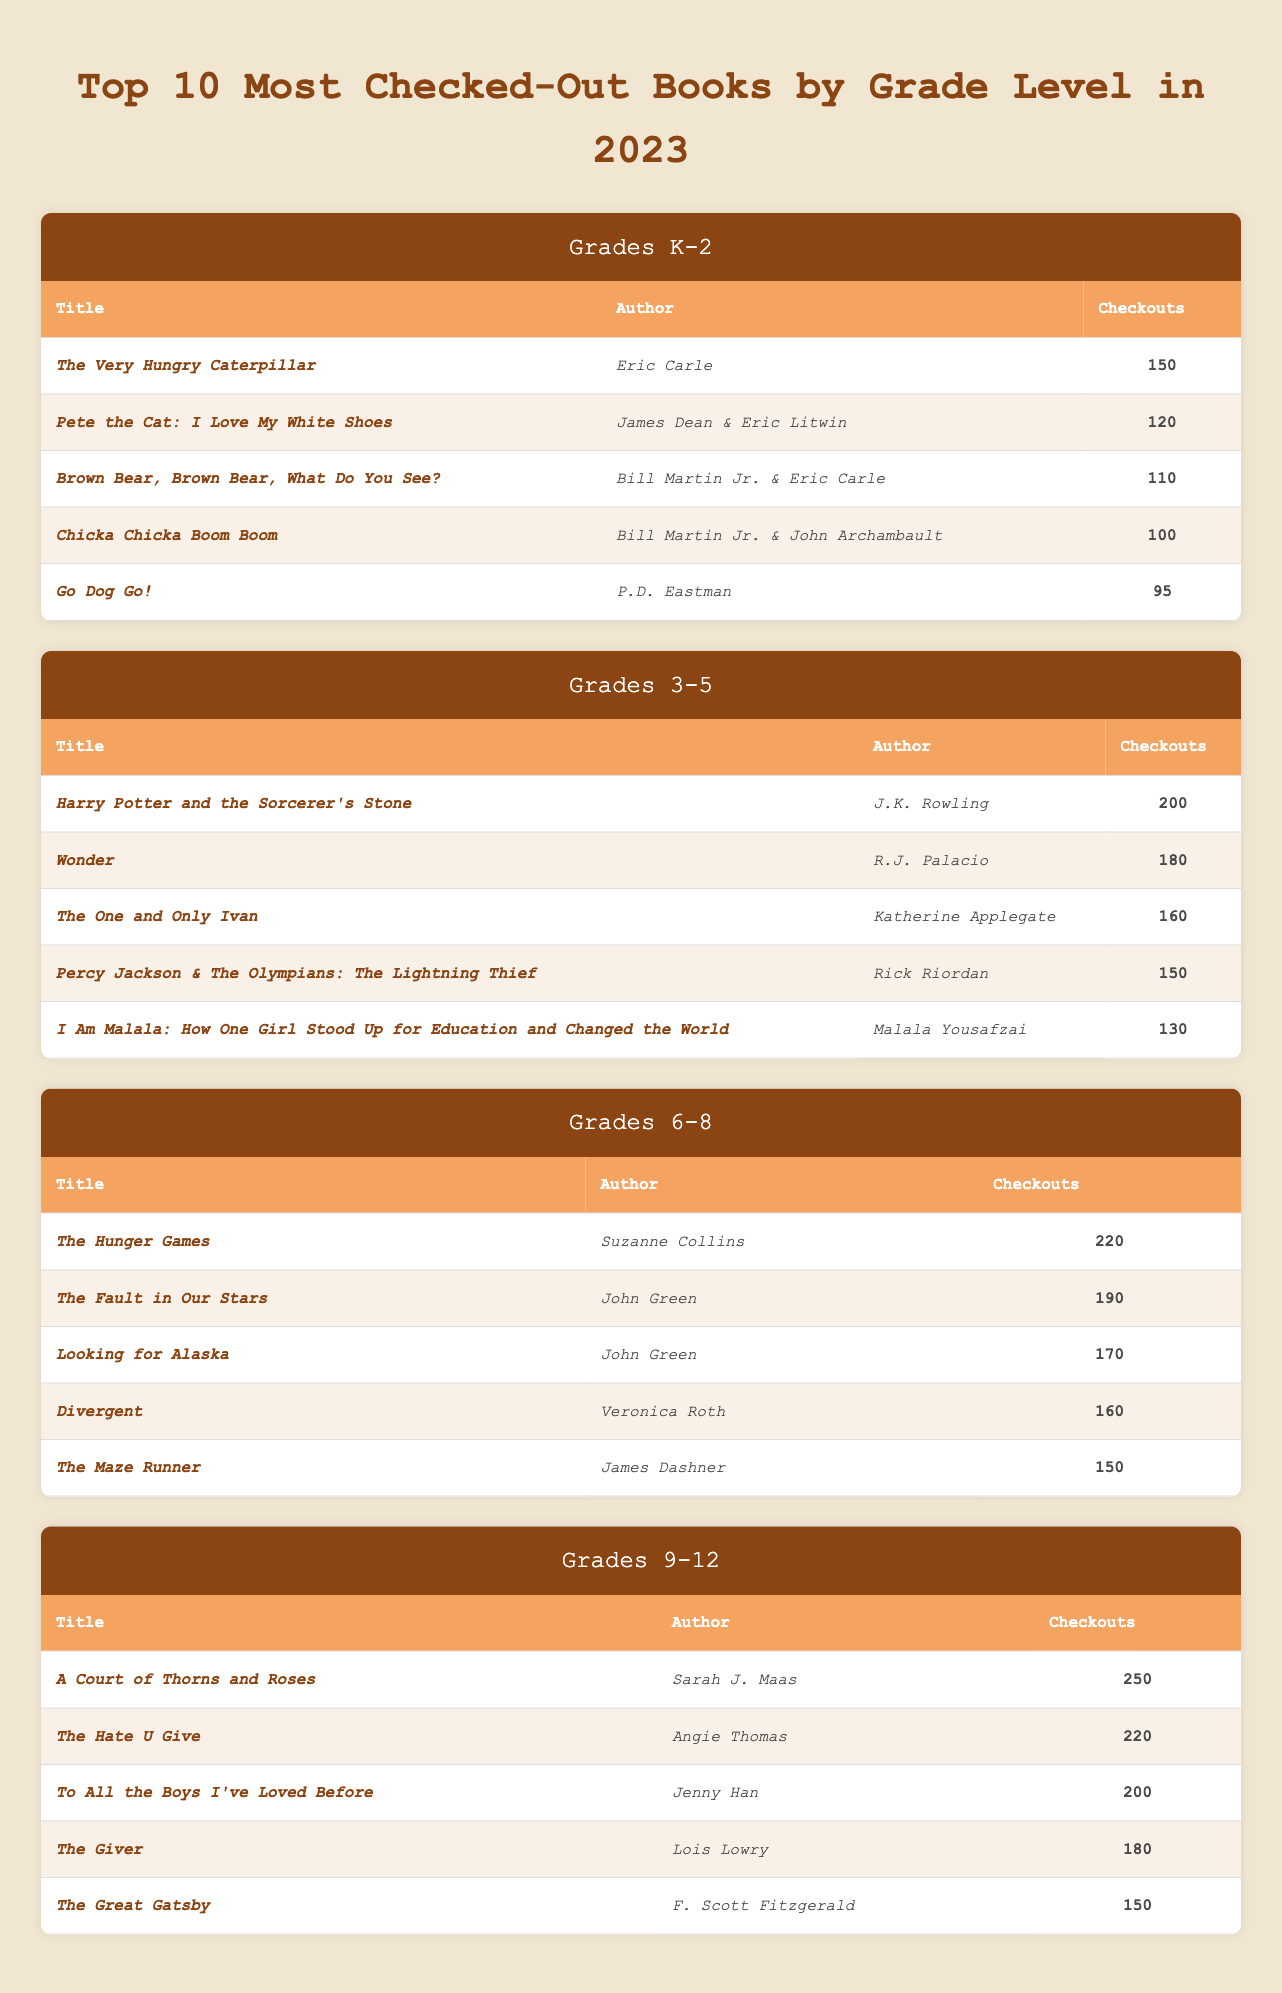What is the title of the most checked-out book for grades K-2? In the K-2 section, the first book listed is _The Very Hungry Caterpillar_, which has the highest number of checkouts (150).
Answer: _The Very Hungry Caterpillar_ How many checkouts did _The Hunger Games_ receive? In the 6-8 section, _The Hunger Games_ is recorded with 220 checkouts, as indicated in the table.
Answer: 220 Which grade level has the highest total checkouts for its top 5 books? For grade 9-12, the total checkouts of the top 5 books are calculated: 250 + 220 + 200 + 180 + 150 = 1100. For other grades, the totals are: K-2 (575), 3-5 (920), and 6-8 (1030). 9-12 has the highest total with 1100 checkouts.
Answer: 9-12 Is _Wonder_ the second most checked-out book in grades 3-5? Looking at the 3-5 section, _Wonder_ is the second book in the list with 180 checkouts, confirming that this statement is true.
Answer: Yes Which author appears most frequently among the top checked-out books across all grades? The authors are: Eric Carle (2 times), J.K. Rowling (1 time), R.J. Palacio (1 time), Katherine Applegate (1 time), Rick Riordan (1 time), Suzanne Collins (1 time), John Green (2 times), Veronica Roth (1 time), Sarah J. Maas (1 time), Angie Thomas (1 time), Jenny Han (1 time), Lois Lowry (1 time), and F. Scott Fitzgerald (1 time). John Green appears twice, therefore he is the most frequent author.
Answer: John Green What is the average number of checkouts for the top 5 books in grades 6-8? Summing the checkouts for the top books (220 + 190 + 170 + 160 + 150 = 1090) and dividing by 5 gives us an average of 1090/5 = 218.
Answer: 218 Do any K-2 books exceed 100 checkouts? Checking the K-2 section: _The Very Hungry Caterpillar_ (150), _Pete the Cat: I Love My White Shoes_ (120), _Brown Bear, Brown Bear, What Do You See?_ (110), and the remaining books have lower checkouts. Therefore, multiple books exceed 100 checkouts.
Answer: Yes Which book had the least number of checkouts in grades 3-5? The last book listed for grades 3-5 is _I Am Malala: How One Girl Stood Up for Education and Changed the World_, with 130 checkouts, indicating it had the least count in that group.
Answer: _I Am Malala: How One Girl Stood Up for Education and Changed the World_ What is the difference in checkouts between the most popular book in grades 9-12 and grades 6-8? For grades 9-12, _A Court of Thorns and Roses_ has 250 checkouts, and for grades 6-8, _The Hunger Games_ has 220 checkouts. The difference is 250 - 220 = 30.
Answer: 30 How many books combined are checked out more than 150 times in grades 6-8? In the 6-8 section, two books exceed 150 checkouts: _The Hunger Games_ (220) and _The Fault in Our Stars_ (190); _Looking for Alaska_ (170) and _Divergent_ (160) also meet this criterion. Thus, there are 4 books that are checked out more than 150 times.
Answer: 4 